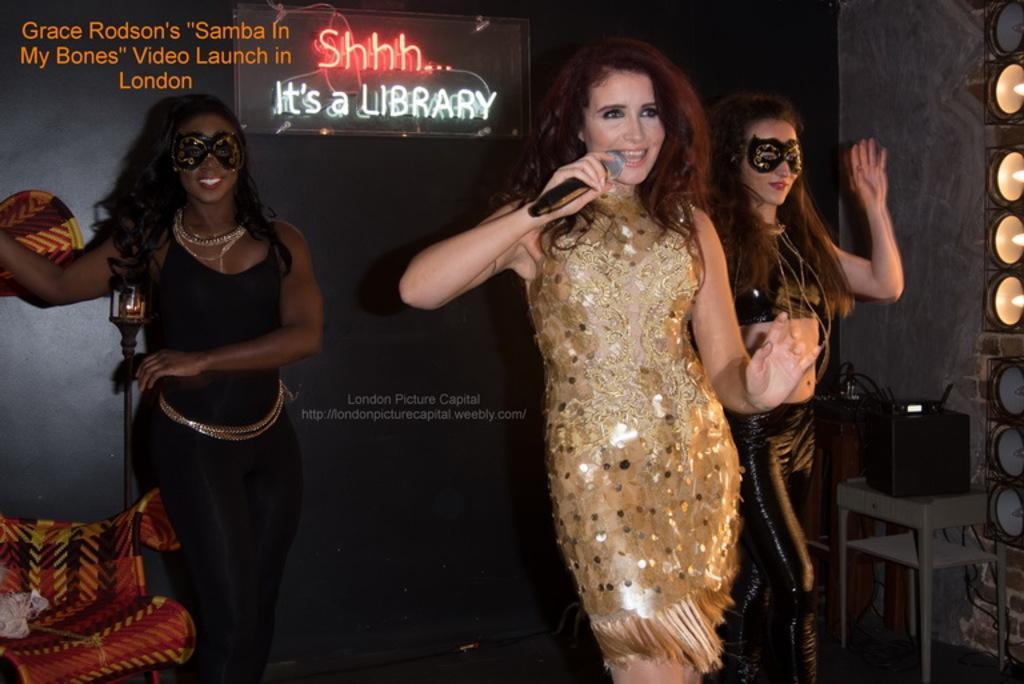Can you describe this image briefly? In this image we can see ladies standing. The lady standing in the center is holding a mic. In the background there is a board. At the bottom we can see a chair. On the right there are lights and we can see a speaker placed on the stand. There is text. 